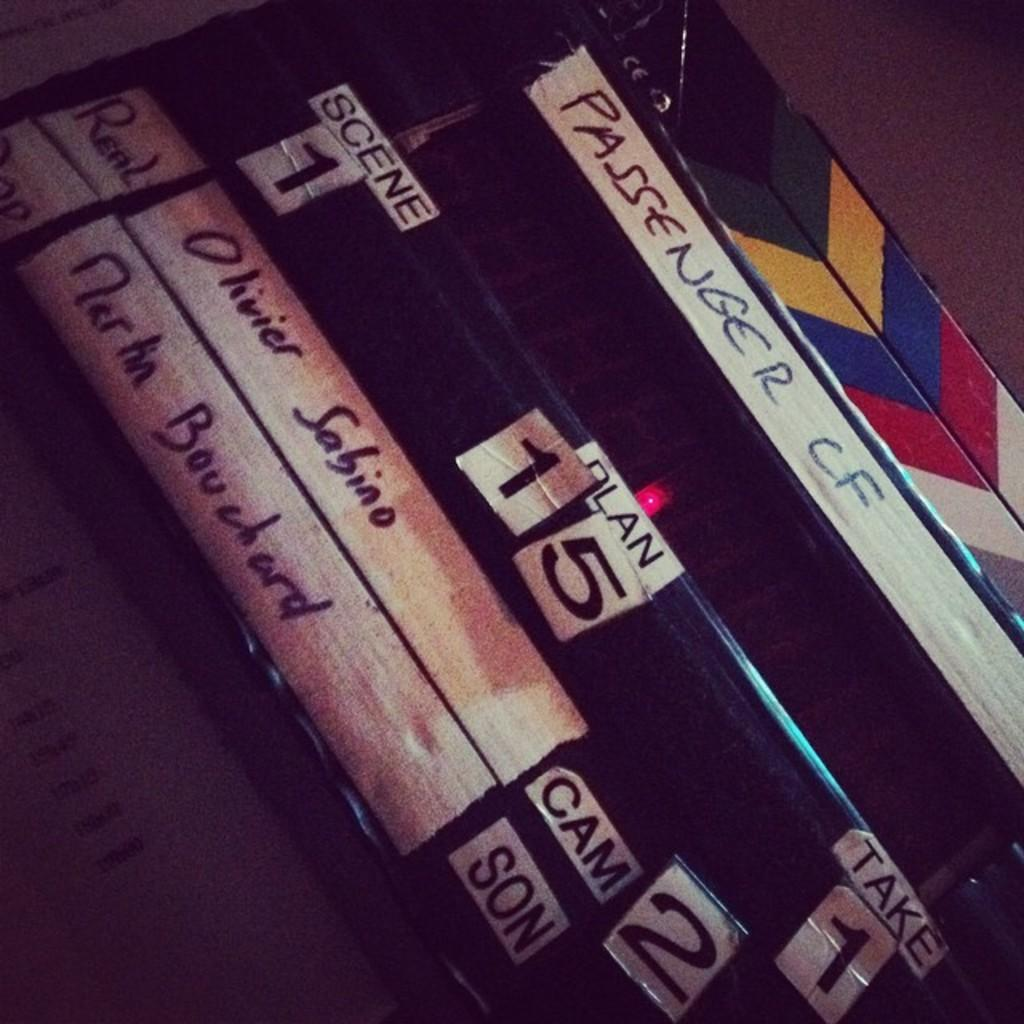<image>
Render a clear and concise summary of the photo. A scene board for the movie Passenger shows the scene and take numbers. 